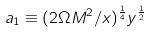<formula> <loc_0><loc_0><loc_500><loc_500>a _ { 1 } \equiv ( 2 \Omega M ^ { 2 } / x ) ^ { \frac { 1 } { 4 } } y ^ { \frac { 1 } { 2 } }</formula> 